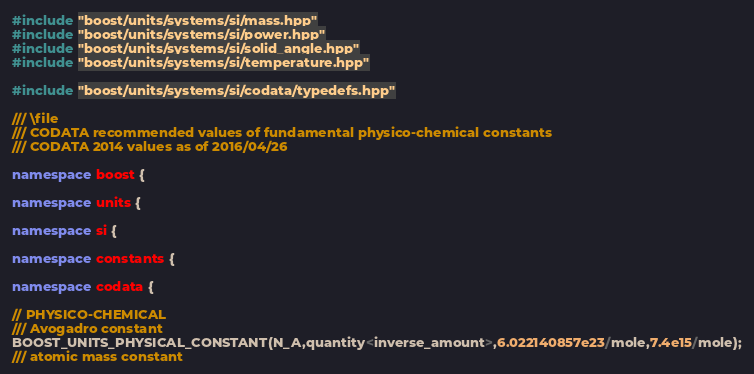Convert code to text. <code><loc_0><loc_0><loc_500><loc_500><_C++_>#include "boost/units/systems/si/mass.hpp"
#include "boost/units/systems/si/power.hpp"
#include "boost/units/systems/si/solid_angle.hpp"
#include "boost/units/systems/si/temperature.hpp"

#include "boost/units/systems/si/codata/typedefs.hpp"

/// \file
/// CODATA recommended values of fundamental physico-chemical constants
/// CODATA 2014 values as of 2016/04/26

namespace boost {

namespace units { 

namespace si {
                            
namespace constants {

namespace codata {

// PHYSICO-CHEMICAL
/// Avogadro constant
BOOST_UNITS_PHYSICAL_CONSTANT(N_A,quantity<inverse_amount>,6.022140857e23/mole,7.4e15/mole);
/// atomic mass constant</code> 